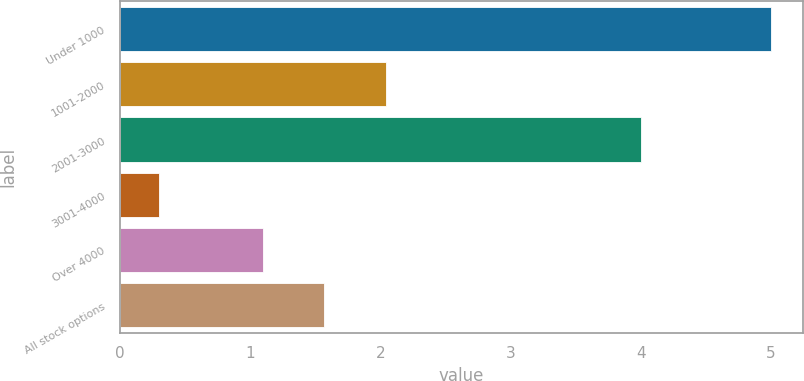<chart> <loc_0><loc_0><loc_500><loc_500><bar_chart><fcel>Under 1000<fcel>1001-2000<fcel>2001-3000<fcel>3001-4000<fcel>Over 4000<fcel>All stock options<nl><fcel>5<fcel>2.04<fcel>4<fcel>0.3<fcel>1.1<fcel>1.57<nl></chart> 